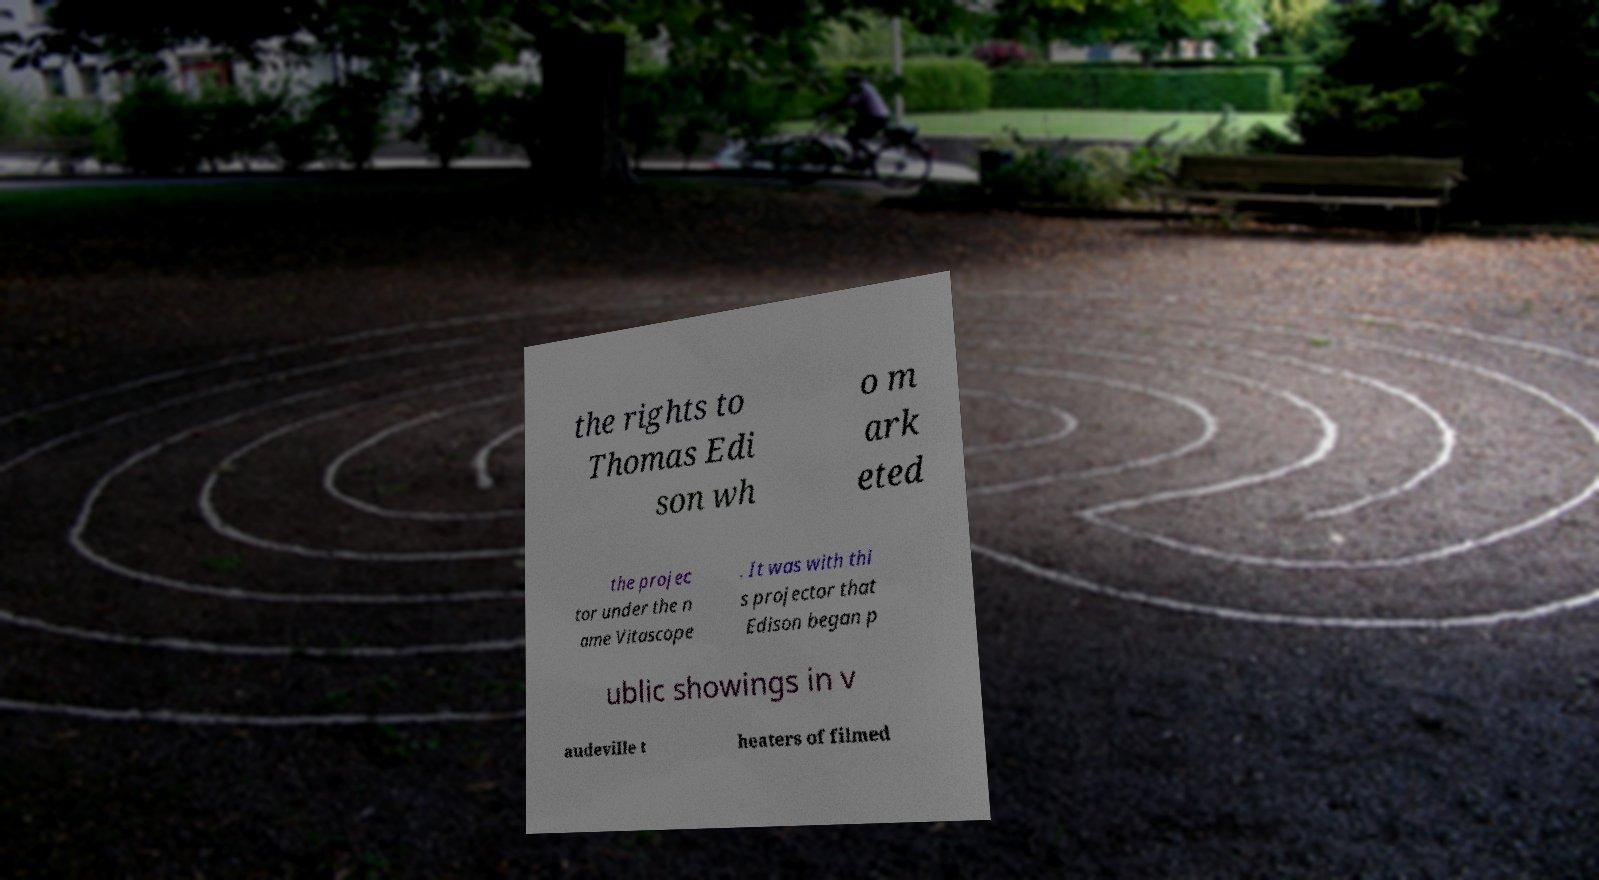Can you read and provide the text displayed in the image?This photo seems to have some interesting text. Can you extract and type it out for me? the rights to Thomas Edi son wh o m ark eted the projec tor under the n ame Vitascope . It was with thi s projector that Edison began p ublic showings in v audeville t heaters of filmed 